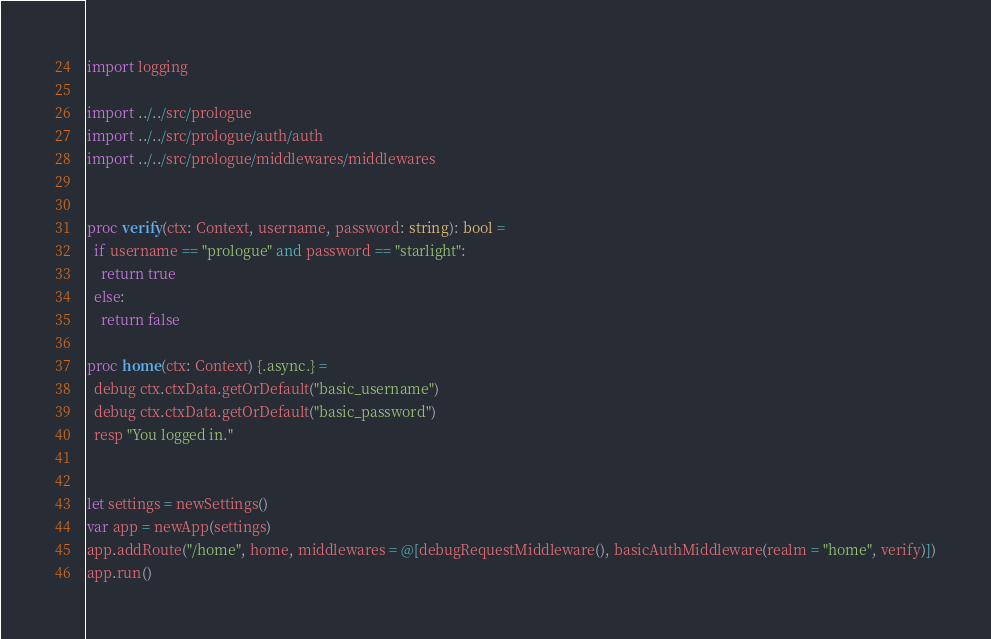<code> <loc_0><loc_0><loc_500><loc_500><_Nim_>import logging

import ../../src/prologue
import ../../src/prologue/auth/auth
import ../../src/prologue/middlewares/middlewares


proc verify(ctx: Context, username, password: string): bool =
  if username == "prologue" and password == "starlight":
    return true
  else:
    return false

proc home(ctx: Context) {.async.} =
  debug ctx.ctxData.getOrDefault("basic_username")
  debug ctx.ctxData.getOrDefault("basic_password")
  resp "You logged in."


let settings = newSettings()
var app = newApp(settings)
app.addRoute("/home", home, middlewares = @[debugRequestMiddleware(), basicAuthMiddleware(realm = "home", verify)])
app.run()
</code> 